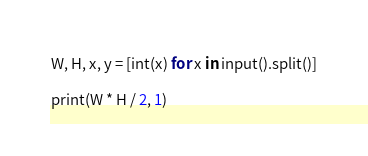Convert code to text. <code><loc_0><loc_0><loc_500><loc_500><_Python_>W, H, x, y = [int(x) for x in input().split()]

print(W * H / 2, 1)
</code> 